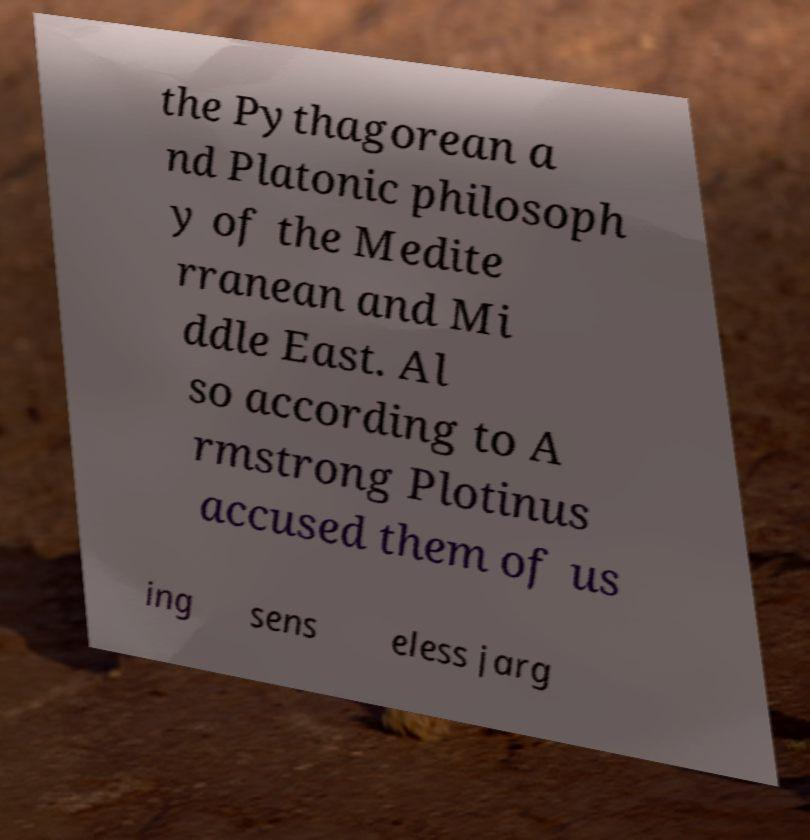Could you assist in decoding the text presented in this image and type it out clearly? the Pythagorean a nd Platonic philosoph y of the Medite rranean and Mi ddle East. Al so according to A rmstrong Plotinus accused them of us ing sens eless jarg 